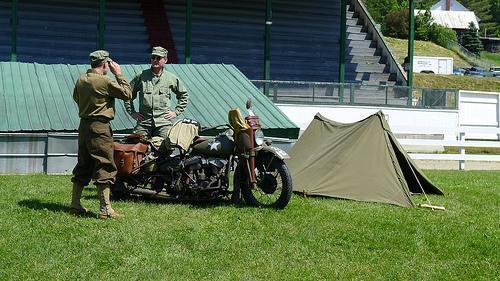How many men are in the picture?
Give a very brief answer. 2. How many tents are in the picture?
Give a very brief answer. 1. 